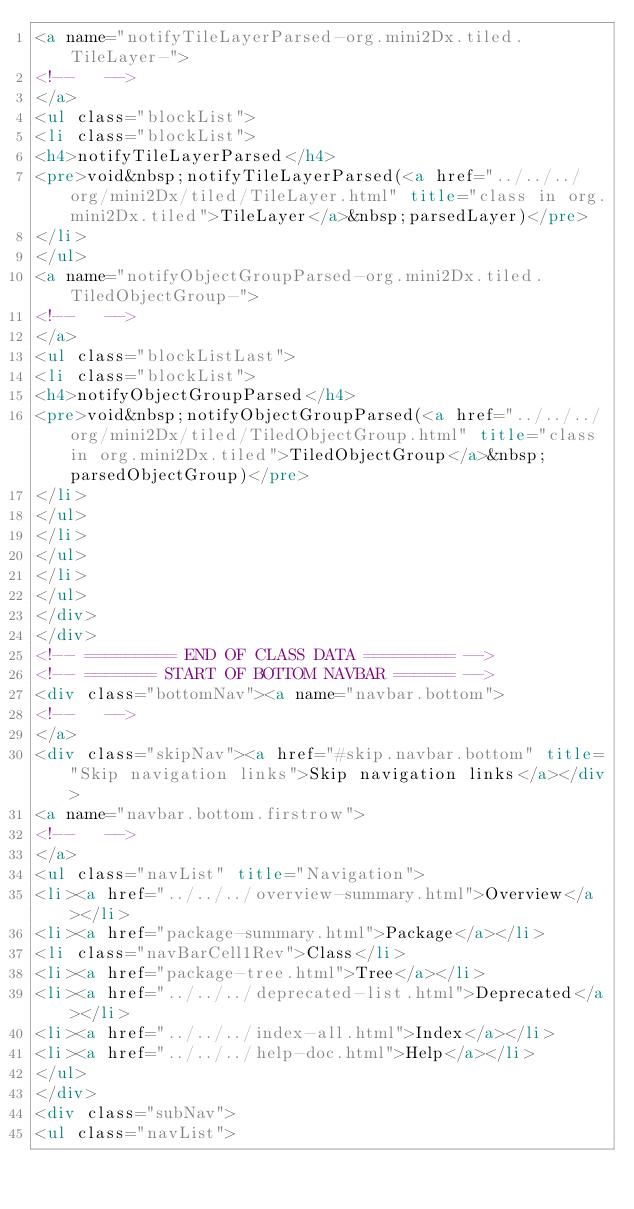<code> <loc_0><loc_0><loc_500><loc_500><_HTML_><a name="notifyTileLayerParsed-org.mini2Dx.tiled.TileLayer-">
<!--   -->
</a>
<ul class="blockList">
<li class="blockList">
<h4>notifyTileLayerParsed</h4>
<pre>void&nbsp;notifyTileLayerParsed(<a href="../../../org/mini2Dx/tiled/TileLayer.html" title="class in org.mini2Dx.tiled">TileLayer</a>&nbsp;parsedLayer)</pre>
</li>
</ul>
<a name="notifyObjectGroupParsed-org.mini2Dx.tiled.TiledObjectGroup-">
<!--   -->
</a>
<ul class="blockListLast">
<li class="blockList">
<h4>notifyObjectGroupParsed</h4>
<pre>void&nbsp;notifyObjectGroupParsed(<a href="../../../org/mini2Dx/tiled/TiledObjectGroup.html" title="class in org.mini2Dx.tiled">TiledObjectGroup</a>&nbsp;parsedObjectGroup)</pre>
</li>
</ul>
</li>
</ul>
</li>
</ul>
</div>
</div>
<!-- ========= END OF CLASS DATA ========= -->
<!-- ======= START OF BOTTOM NAVBAR ====== -->
<div class="bottomNav"><a name="navbar.bottom">
<!--   -->
</a>
<div class="skipNav"><a href="#skip.navbar.bottom" title="Skip navigation links">Skip navigation links</a></div>
<a name="navbar.bottom.firstrow">
<!--   -->
</a>
<ul class="navList" title="Navigation">
<li><a href="../../../overview-summary.html">Overview</a></li>
<li><a href="package-summary.html">Package</a></li>
<li class="navBarCell1Rev">Class</li>
<li><a href="package-tree.html">Tree</a></li>
<li><a href="../../../deprecated-list.html">Deprecated</a></li>
<li><a href="../../../index-all.html">Index</a></li>
<li><a href="../../../help-doc.html">Help</a></li>
</ul>
</div>
<div class="subNav">
<ul class="navList"></code> 